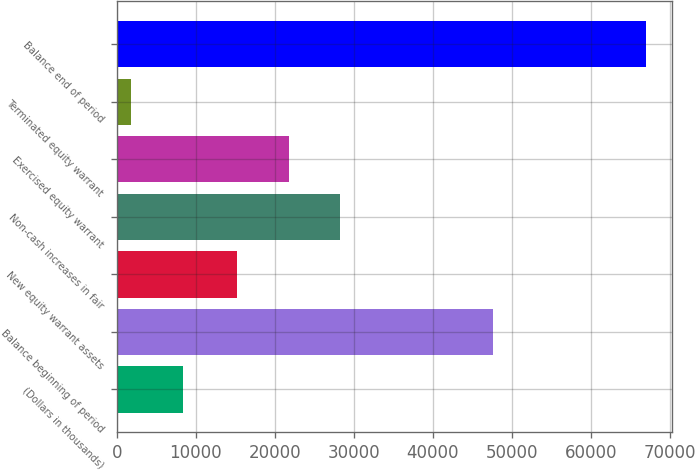<chart> <loc_0><loc_0><loc_500><loc_500><bar_chart><fcel>(Dollars in thousands)<fcel>Balance beginning of period<fcel>New equity warrant assets<fcel>Non-cash increases in fair<fcel>Exercised equity warrant<fcel>Terminated equity warrant<fcel>Balance end of period<nl><fcel>8320.7<fcel>47565<fcel>15240<fcel>28269.4<fcel>21754.7<fcel>1806<fcel>66953<nl></chart> 